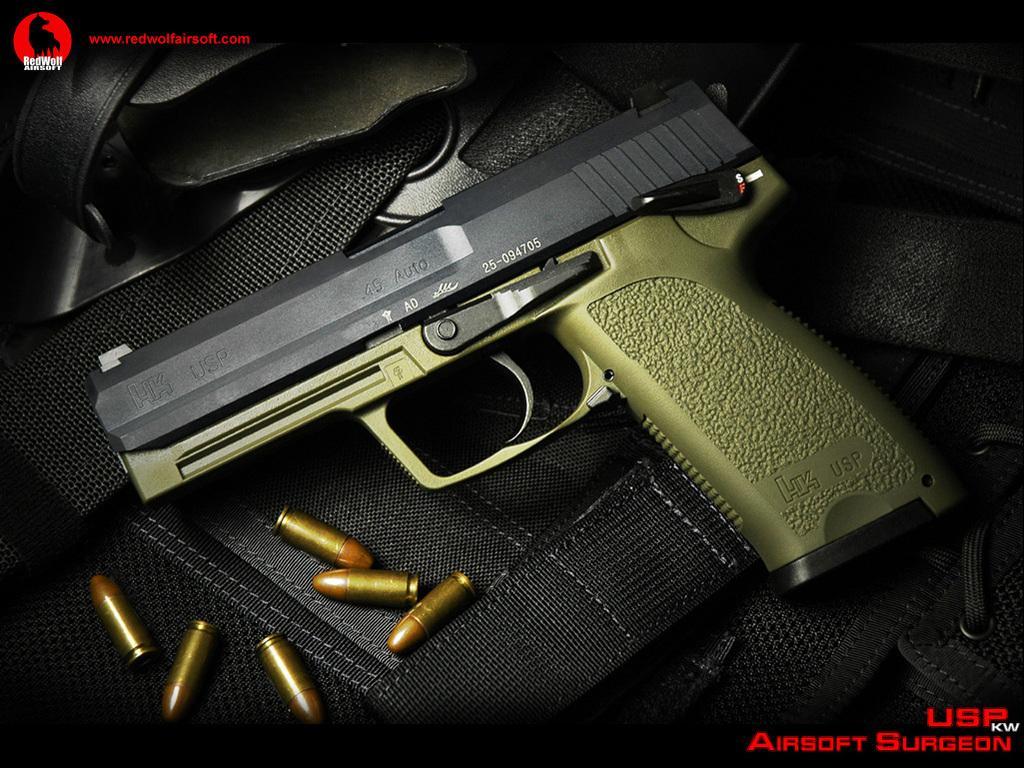Please provide a concise description of this image. In this picture I can see there is a gun and there are some bullets placed on a black surface. 